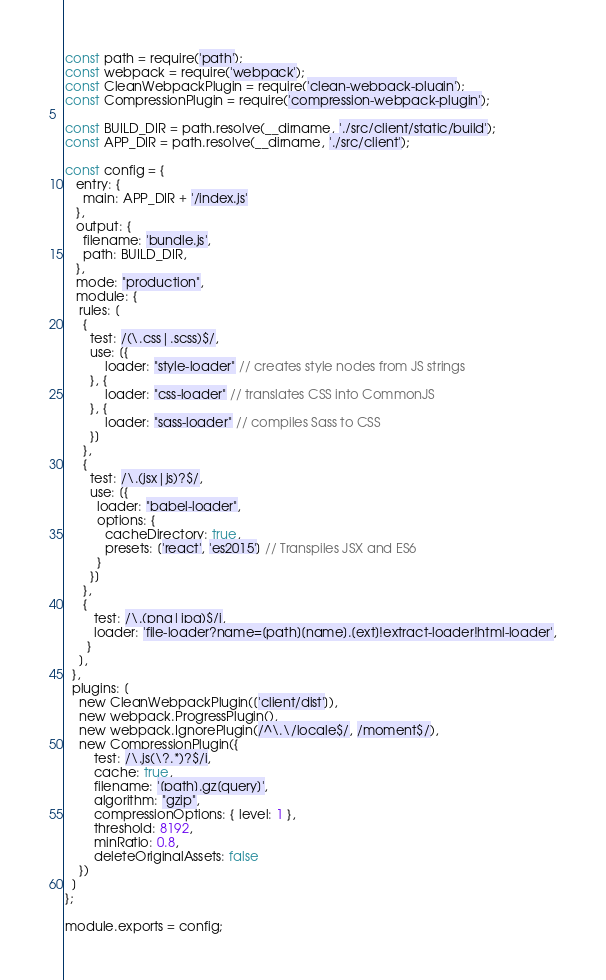<code> <loc_0><loc_0><loc_500><loc_500><_JavaScript_>const path = require('path');
const webpack = require('webpack');
const CleanWebpackPlugin = require('clean-webpack-plugin');
const CompressionPlugin = require('compression-webpack-plugin');

const BUILD_DIR = path.resolve(__dirname, './src/client/static/build');
const APP_DIR = path.resolve(__dirname, './src/client');

const config = {
   entry: {
     main: APP_DIR + '/index.js'
   },
   output: {
     filename: 'bundle.js',
     path: BUILD_DIR,
   },
   mode: "production",
   module: {
    rules: [
     {
       test: /(\.css|.scss)$/,
       use: [{
           loader: "style-loader" // creates style nodes from JS strings
       }, {
           loader: "css-loader" // translates CSS into CommonJS
       }, {
           loader: "sass-loader" // compiles Sass to CSS
       }]
     },
     {
       test: /\.(jsx|js)?$/,
       use: [{
         loader: "babel-loader",
         options: {
           cacheDirectory: true,
           presets: ['react', 'es2015'] // Transpiles JSX and ES6
         }
       }]
     },
     {
        test: /\.(png|jpg)$/i,
        loader: 'file-loader?name=[path][name].[ext]!extract-loader!html-loader',
      }
    ],
  },
  plugins: [
    new CleanWebpackPlugin(['client/dist']),
    new webpack.ProgressPlugin(),
    new webpack.IgnorePlugin(/^\.\/locale$/, /moment$/),
    new CompressionPlugin({
        test: /\.js(\?.*)?$/i,
        cache: true,
        filename: '[path].gz[query]',
        algorithm: "gzip",
        compressionOptions: { level: 1 },
        threshold: 8192,
        minRatio: 0.8,
        deleteOriginalAssets: false
    })
  ]
};

module.exports = config;</code> 